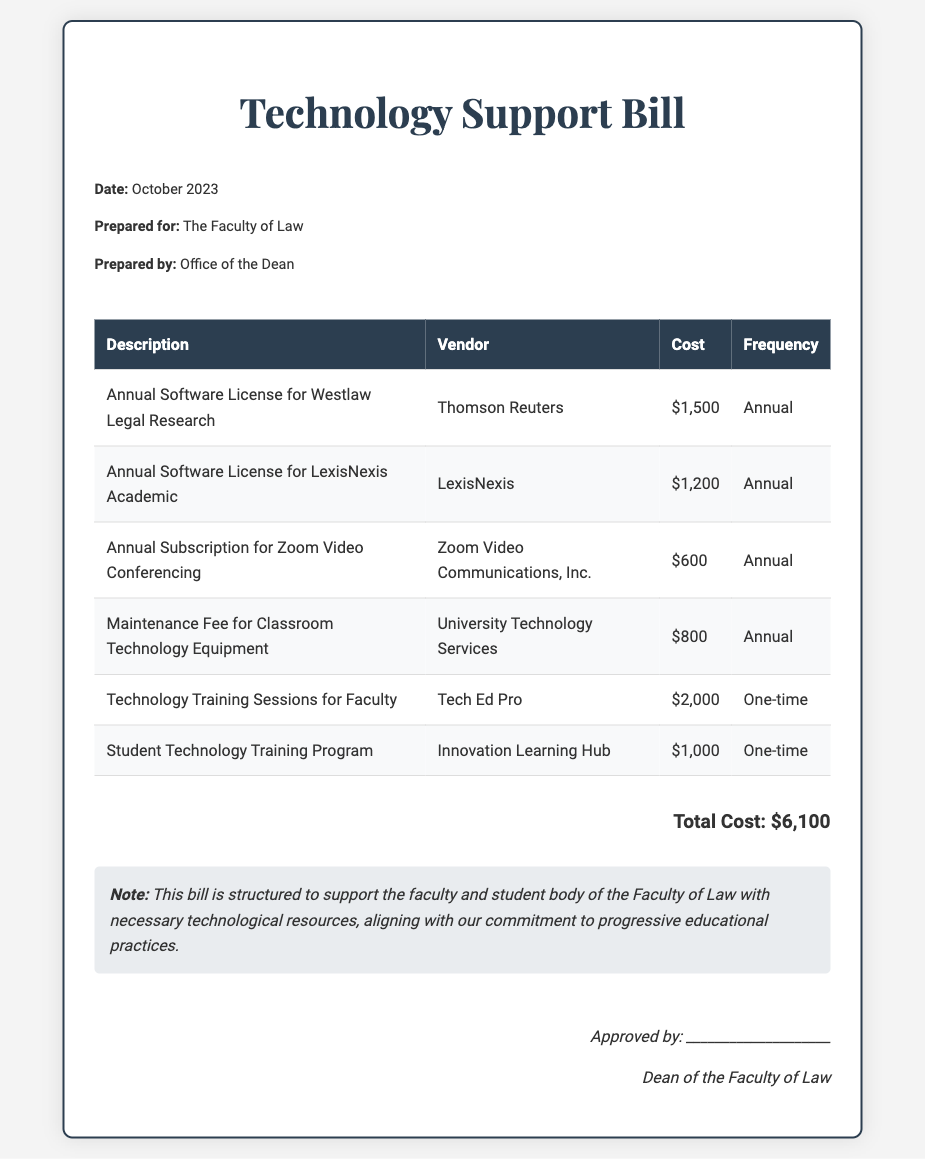What is the total cost of the technology support bill? The total cost is presented at the bottom of the document summarizing all expenses incurred, which is $6,100.
Answer: $6,100 Which vendor provides the annual software license for Westlaw Legal Research? The document lists the vendor alongside each respective service, showing Thomson Reuters for this license.
Answer: Thomson Reuters How much does the technology training sessions for faculty cost? The cost for faculty technology training is stated explicitly in the table as $2,000, indicating its one-time fee.
Answer: $2,000 What is the frequency of the maintenance fee for classroom technology equipment? The frequency for the maintenance fee is categorized in the table highlighting it as an annual cost.
Answer: Annual Who prepared the Technology Support Bill document? The bill indicates that it was prepared by the Office of the Dean as part of its information section.
Answer: Office of the Dean What type of training program is provided for students? The document specifies that it's a Student Technology Training Program, aimed at enhancing student skills in technology.
Answer: Student Technology Training Program Which software license costs $1,200? Among the list of software licenses, the specific license for LexisNexis Academic is stated to have this exact cost.
Answer: LexisNexis Academic How many vendors are listed in the bill? By counting the distinct vendors presented in the tables, there are a total of five vendors provided throughout the document.
Answer: Five What is the date of the bill? The date can be found in the header section of the document, stating October 2023 being the preparation date.
Answer: October 2023 What kind of note is provided at the bottom of the document? The note emphasizes the purpose and alignment of the bill with progressive educational practices, indicating its supportive intent.
Answer: Note 